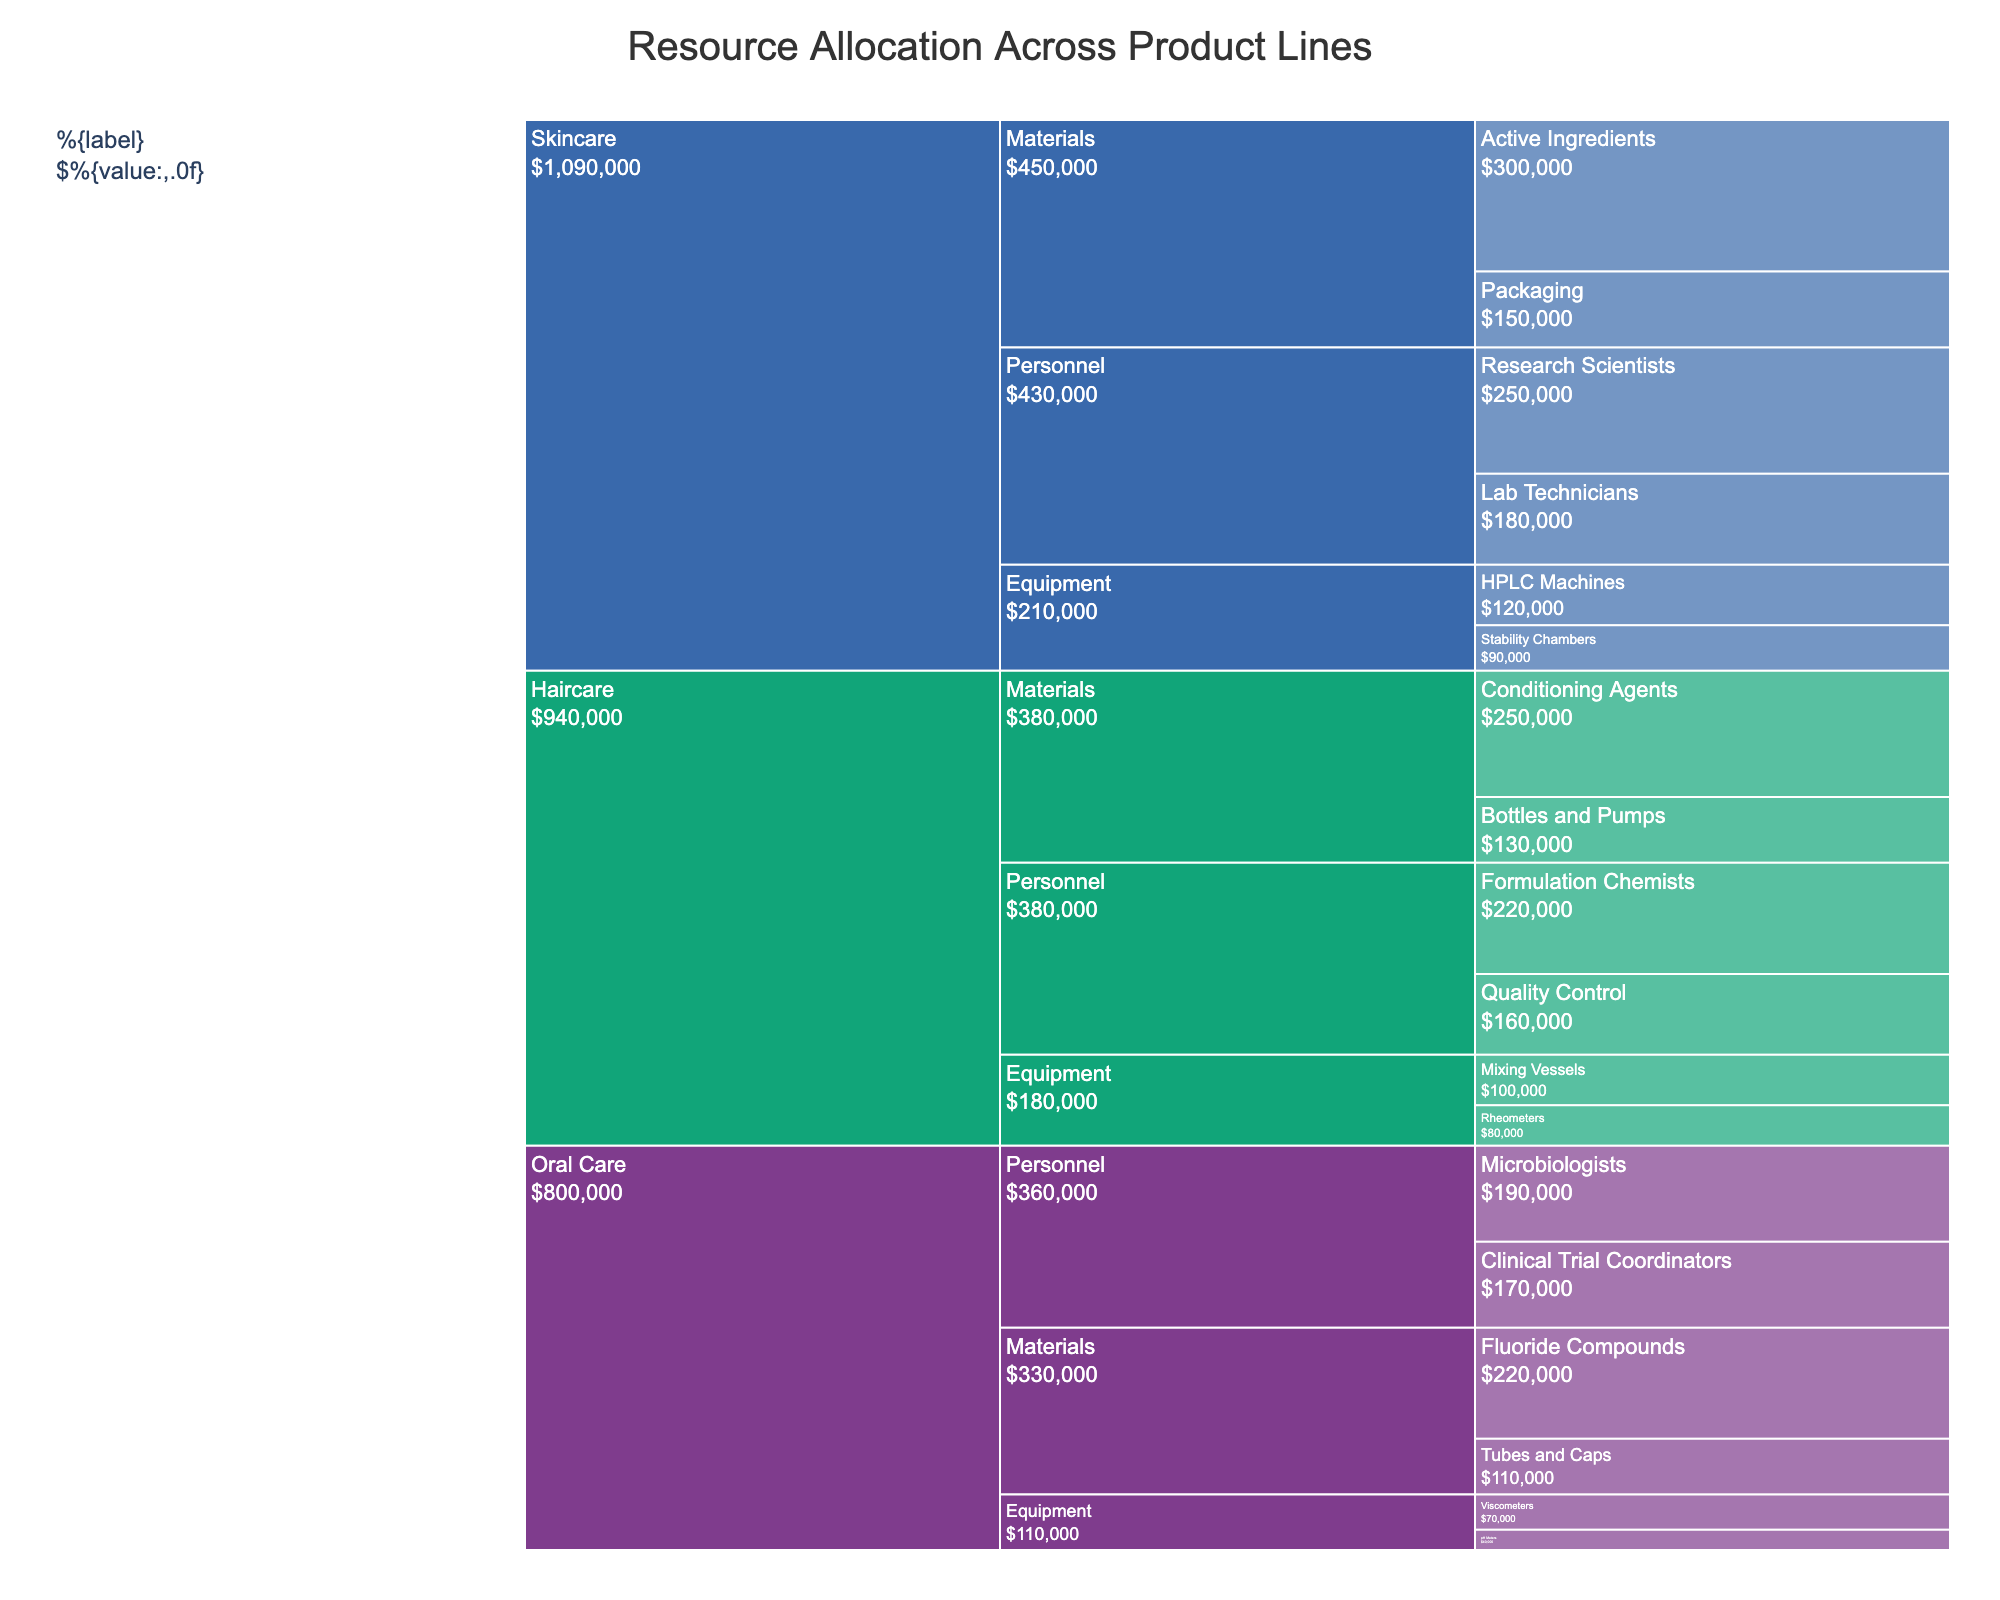What is the title of the chart? The title of the chart is located at the top and provides a summary of what the chart represents.
Answer: Resource Allocation Across Product Lines Which product line has the highest resource allocation for personnel? Look at the different product lines under the "Personnel" category and sum the values for each product line. The highest sum will give you the answer.
Answer: Skincare How much was spent on equipment for Haircare? Check the "Haircare" product line and sum the values under the "Equipment" category. Specifically, add the amounts for Rheometers and Mixing Vessels.
Answer: $180,000 Which subcategory in Skincare has the highest allocation? Look within the Skincare product line and identify the subcategory with the highest value, considering Personnel, Equipment, and Materials.
Answer: Active Ingredients Compare the allocation for Active Ingredients in Skincare with Conditioning Agents in Haircare. Which is higher and by how much? Look at the values for Active Ingredients in Skincare and Conditioning Agents in Haircare and compute the difference.
Answer: Active Ingredients is higher by $50,000 What are the three main categories of resource allocation in the chart? The main categories are visible at the second level in the icicle chart under any product line.
Answer: Personnel, Equipment, Materials Which Product Line has the least expenditure on Materials? Check the values under the "Materials" category for each product line and identify the one with the lowest total allocation.
Answer: Oral Care What is the total allocation for Oral Care? Sum up all the values for Oral Care in Personnel, Equipment, and Materials.
Answer: $800,000 Which product line has the highest allocation in the category "Equipment"? Compare the total Equipment values for each product line: Skincare, Haircare, and Oral Care.
Answer: Skincare In which subcategory and product line combination was the least resource spent? Identify the smallest value from the entire chart and note its subcategory and product line.
Answer: pH Meters in Oral Care 